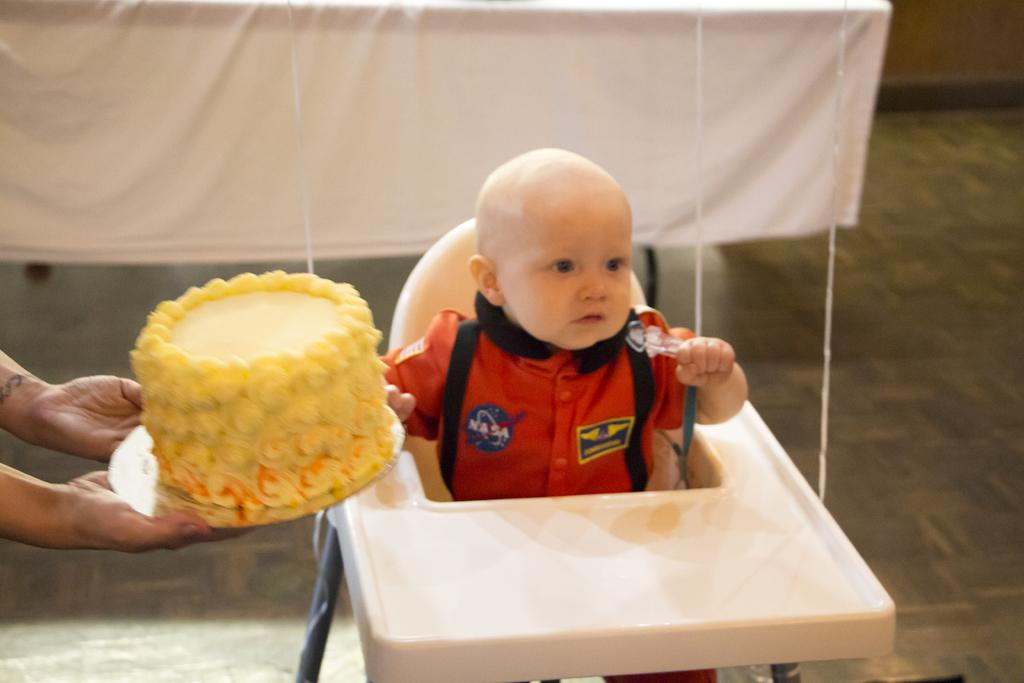What is the person on the left side of the image holding? The person is holding a cake in the image. Where is the baby sitting in the image? The baby is sitting on a chair in the image. What can be seen in the background of the image? There is a white cloth visible in the background of the image. What type of test is being conducted in the image? There is no test being conducted in the image; it features a person holding a cake and a baby sitting on a chair. What holiday is being celebrated in the image? There is no specific holiday mentioned or depicted in the image. 